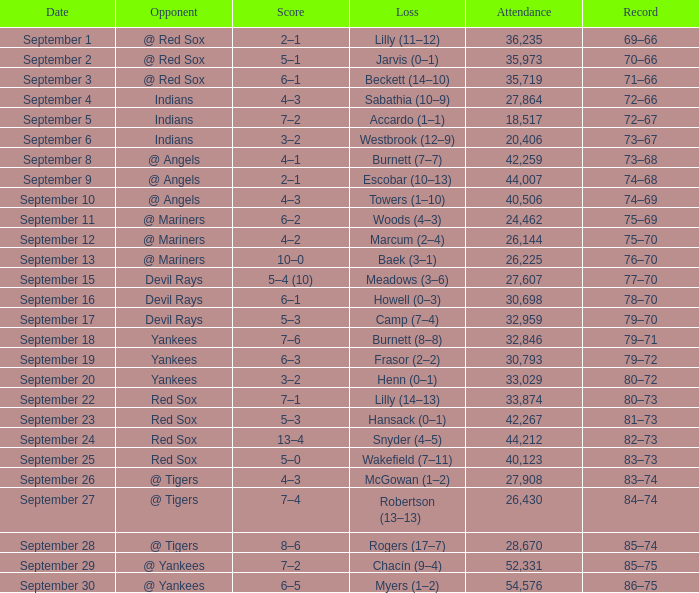On september 19, who is the competing team? Yankees. 